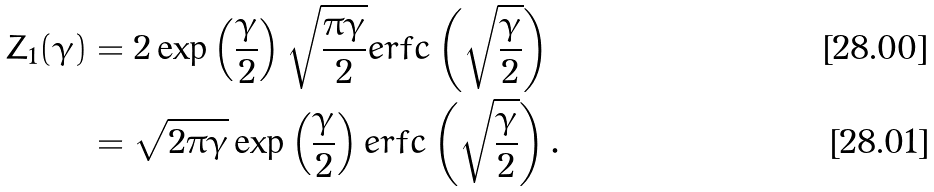Convert formula to latex. <formula><loc_0><loc_0><loc_500><loc_500>Z _ { 1 } ( \gamma ) & = 2 \exp \left ( \frac { \gamma } { 2 } \right ) \sqrt { \frac { \pi \gamma } { 2 } } e r f c \left ( \sqrt { \frac { \gamma } { 2 } } \right ) \\ & = \sqrt { 2 \pi \gamma } \exp \left ( \frac { \gamma } { 2 } \right ) e r f c \left ( \sqrt { \frac { \gamma } { 2 } } \right ) .</formula> 